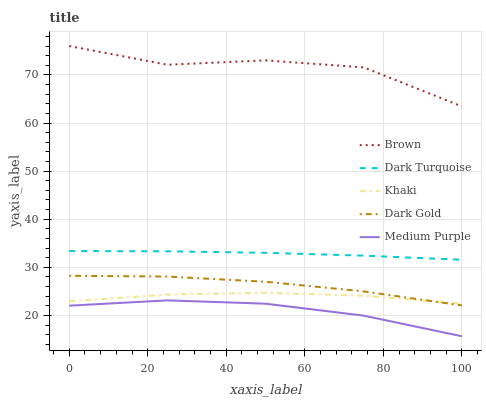Does Medium Purple have the minimum area under the curve?
Answer yes or no. Yes. Does Brown have the maximum area under the curve?
Answer yes or no. Yes. Does Khaki have the minimum area under the curve?
Answer yes or no. No. Does Khaki have the maximum area under the curve?
Answer yes or no. No. Is Dark Turquoise the smoothest?
Answer yes or no. Yes. Is Brown the roughest?
Answer yes or no. Yes. Is Khaki the smoothest?
Answer yes or no. No. Is Khaki the roughest?
Answer yes or no. No. Does Medium Purple have the lowest value?
Answer yes or no. Yes. Does Khaki have the lowest value?
Answer yes or no. No. Does Brown have the highest value?
Answer yes or no. Yes. Does Khaki have the highest value?
Answer yes or no. No. Is Medium Purple less than Khaki?
Answer yes or no. Yes. Is Brown greater than Medium Purple?
Answer yes or no. Yes. Does Khaki intersect Dark Gold?
Answer yes or no. Yes. Is Khaki less than Dark Gold?
Answer yes or no. No. Is Khaki greater than Dark Gold?
Answer yes or no. No. Does Medium Purple intersect Khaki?
Answer yes or no. No. 